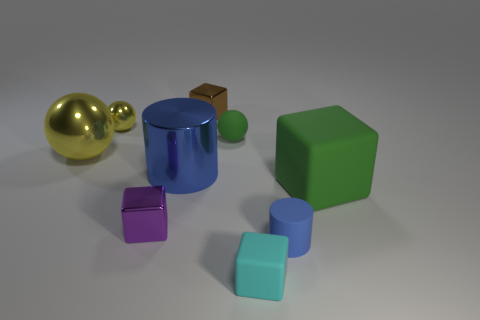Is the number of brown cubes less than the number of small yellow shiny cylinders?
Provide a succinct answer. No. There is a blue object that is behind the green block; does it have the same shape as the blue object that is in front of the small purple object?
Give a very brief answer. Yes. The tiny cylinder is what color?
Your answer should be very brief. Blue. How many matte objects are either tiny cyan cylinders or big yellow balls?
Offer a terse response. 0. What is the color of the other small metallic thing that is the same shape as the tiny brown object?
Ensure brevity in your answer.  Purple. Is there a green rubber sphere?
Your answer should be compact. Yes. Is the blue cylinder that is in front of the large green thing made of the same material as the big object on the right side of the brown metallic block?
Ensure brevity in your answer.  Yes. There is a matte object that is the same color as the large matte cube; what is its shape?
Offer a terse response. Sphere. How many objects are metallic cubes in front of the brown block or blue cylinders that are on the left side of the brown metal object?
Offer a very short reply. 2. There is a rubber object behind the big yellow metal ball; is it the same color as the rubber cube behind the tiny purple cube?
Provide a short and direct response. Yes. 